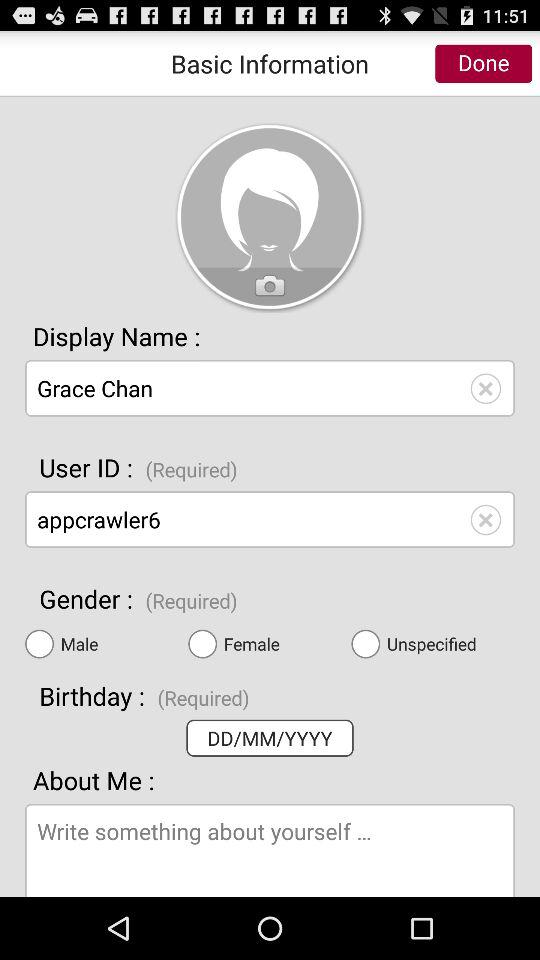What is the email address?
When the provided information is insufficient, respond with <no answer>. <no answer> 